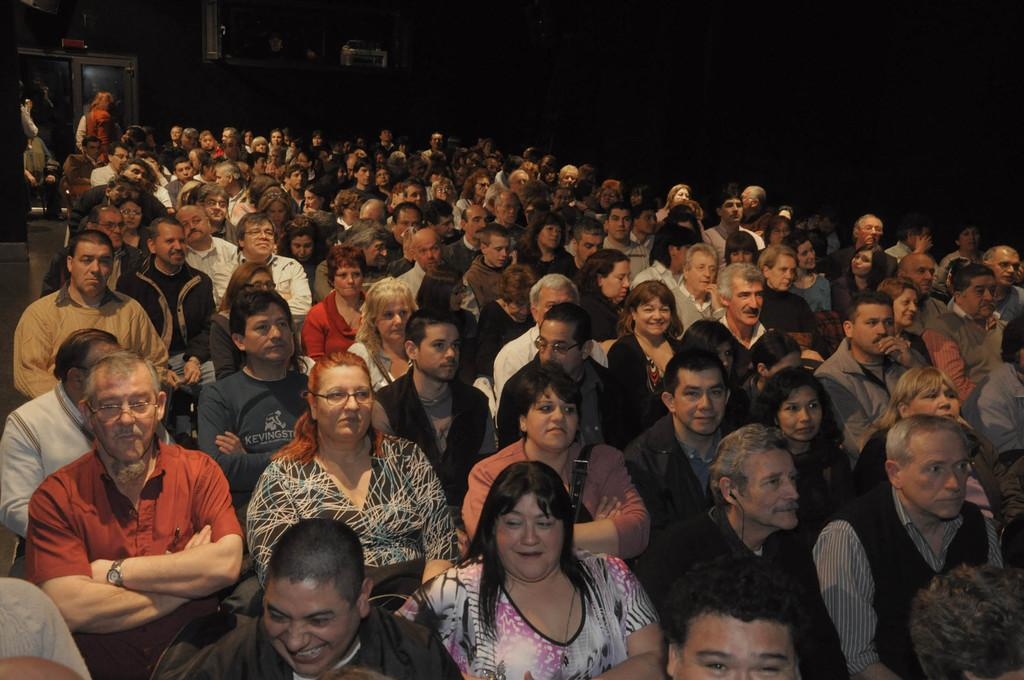What is the general arrangement of people in the image? There are many people seated in the image, with a few people standing at the back. Can you describe any specific features of the room or space in the image? There is a door visible in the image. How is the background of the image depicted? The background of the image is blurred. What type of sack is being used for magic tricks in the image? There is no sack or magic tricks present in the image. Are there any dinosaurs visible in the image? No, there are no dinosaurs present in the image. 